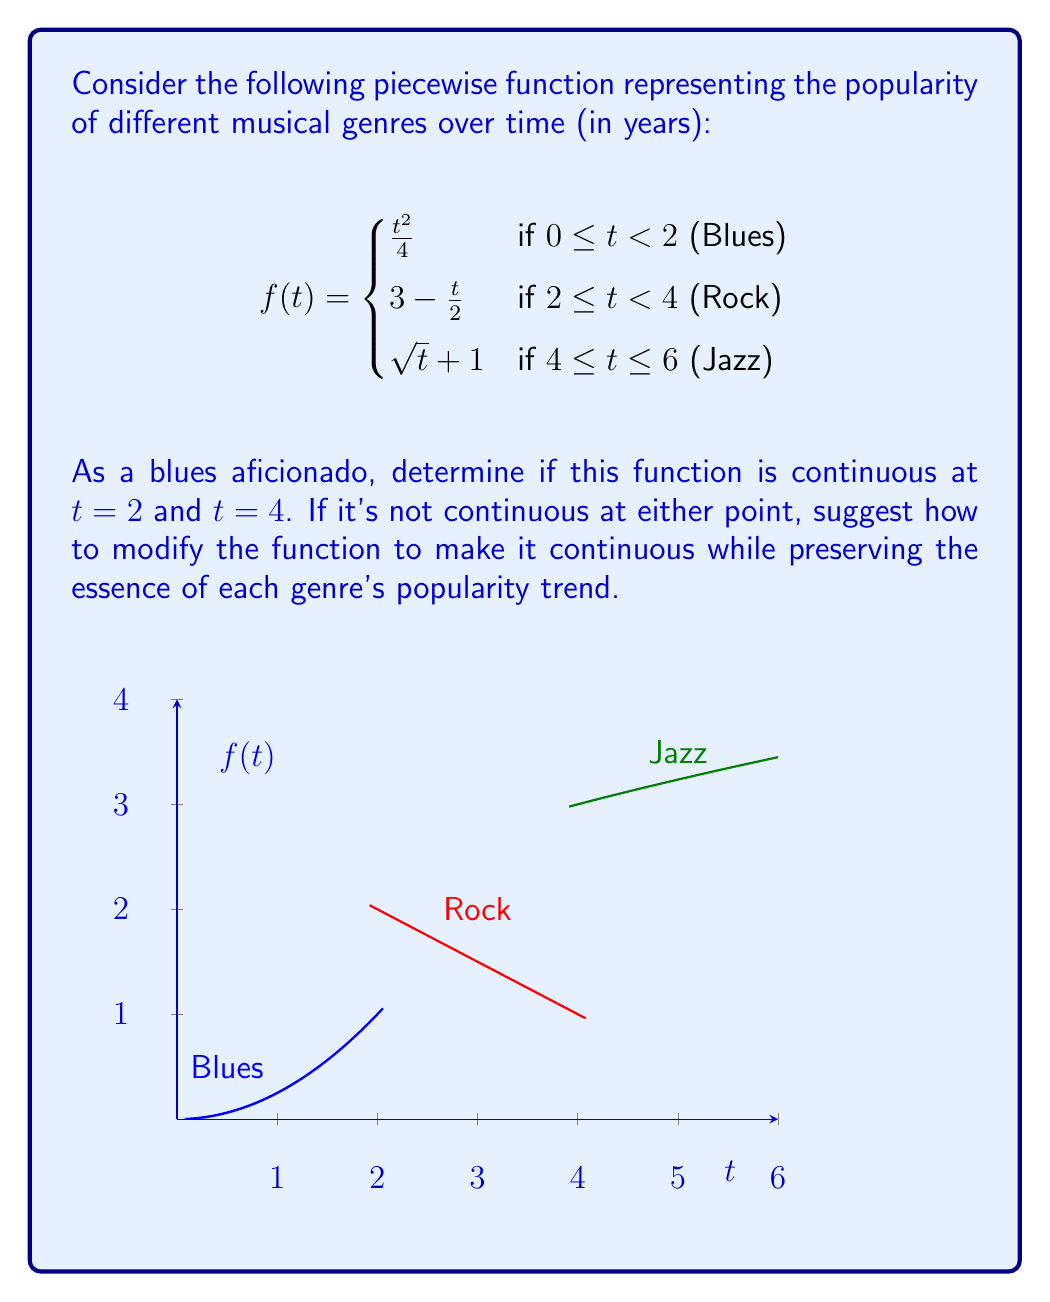Help me with this question. To determine continuity at $t = 2$ and $t = 4$, we need to check three conditions at each point:
1. The function is defined at the point
2. The limit of the function as we approach the point from both sides exists
3. The limit equals the function value at that point

For $t = 2$:

1. $f(2)$ is defined: $f(2) = 3 - \frac{2}{2} = 2$ (Rock function)
2. Left limit: $\lim_{t \to 2^-} \frac{t^2}{4} = \frac{4}{4} = 1$ (Blues function)
   Right limit: $\lim_{t \to 2^+} (3 - \frac{t}{2}) = 2$ (Rock function)
3. The left limit (1) ≠ right limit (2) ≠ $f(2)$

Therefore, $f(t)$ is not continuous at $t = 2$.

For $t = 4$:

1. $f(4)$ is defined: $f(4) = \sqrt{4} + 1 = 3$ (Jazz function)
2. Left limit: $\lim_{t \to 4^-} (3 - \frac{t}{2}) = 1$ (Rock function)
   Right limit: $\lim_{t \to 4^+} (\sqrt{t} + 1) = 3$ (Jazz function)
3. The left limit (1) ≠ right limit (3) = $f(4)$

Therefore, $f(t)$ is not continuous at $t = 4$.

To make the function continuous:

At $t = 2$, modify the Blues function: $\frac{t^2}{4} + 1$ for $0 \leq t < 2$
At $t = 4$, modify the Rock function: $5 - \frac{t}{2}$ for $2 \leq t < 4$

The modified piecewise function would be:

$$f(t) = \begin{cases}
\frac{t^2}{4} + 1 & \text{if } 0 \leq t < 2 \text{ (Blues)} \\
5 - \frac{t}{2} & \text{if } 2 \leq t < 4 \text{ (Rock)} \\
\sqrt{t} + 1 & \text{if } 4 \leq t \leq 6 \text{ (Jazz)}
\end{cases}$$

This preserves the overall trend of each genre while ensuring continuity.
Answer: Not continuous at $t=2$ and $t=4$. Modify Blues: $\frac{t^2}{4} + 1$, Rock: $5 - \frac{t}{2}$. 